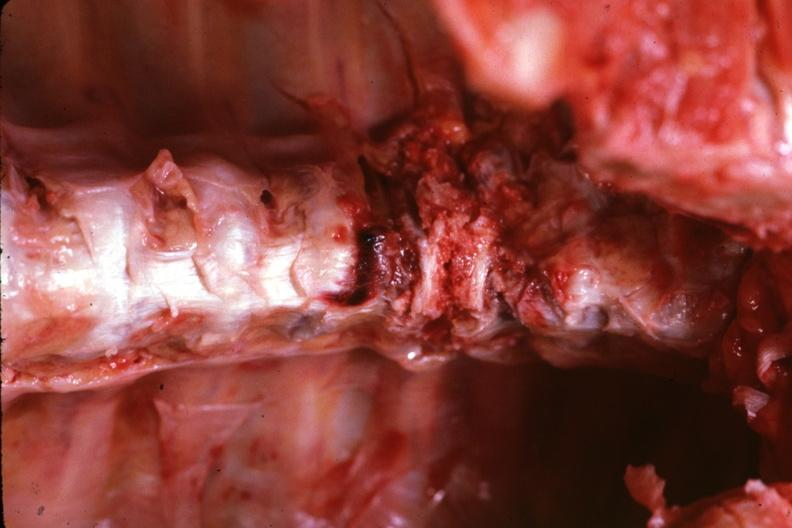s joints present?
Answer the question using a single word or phrase. Yes 